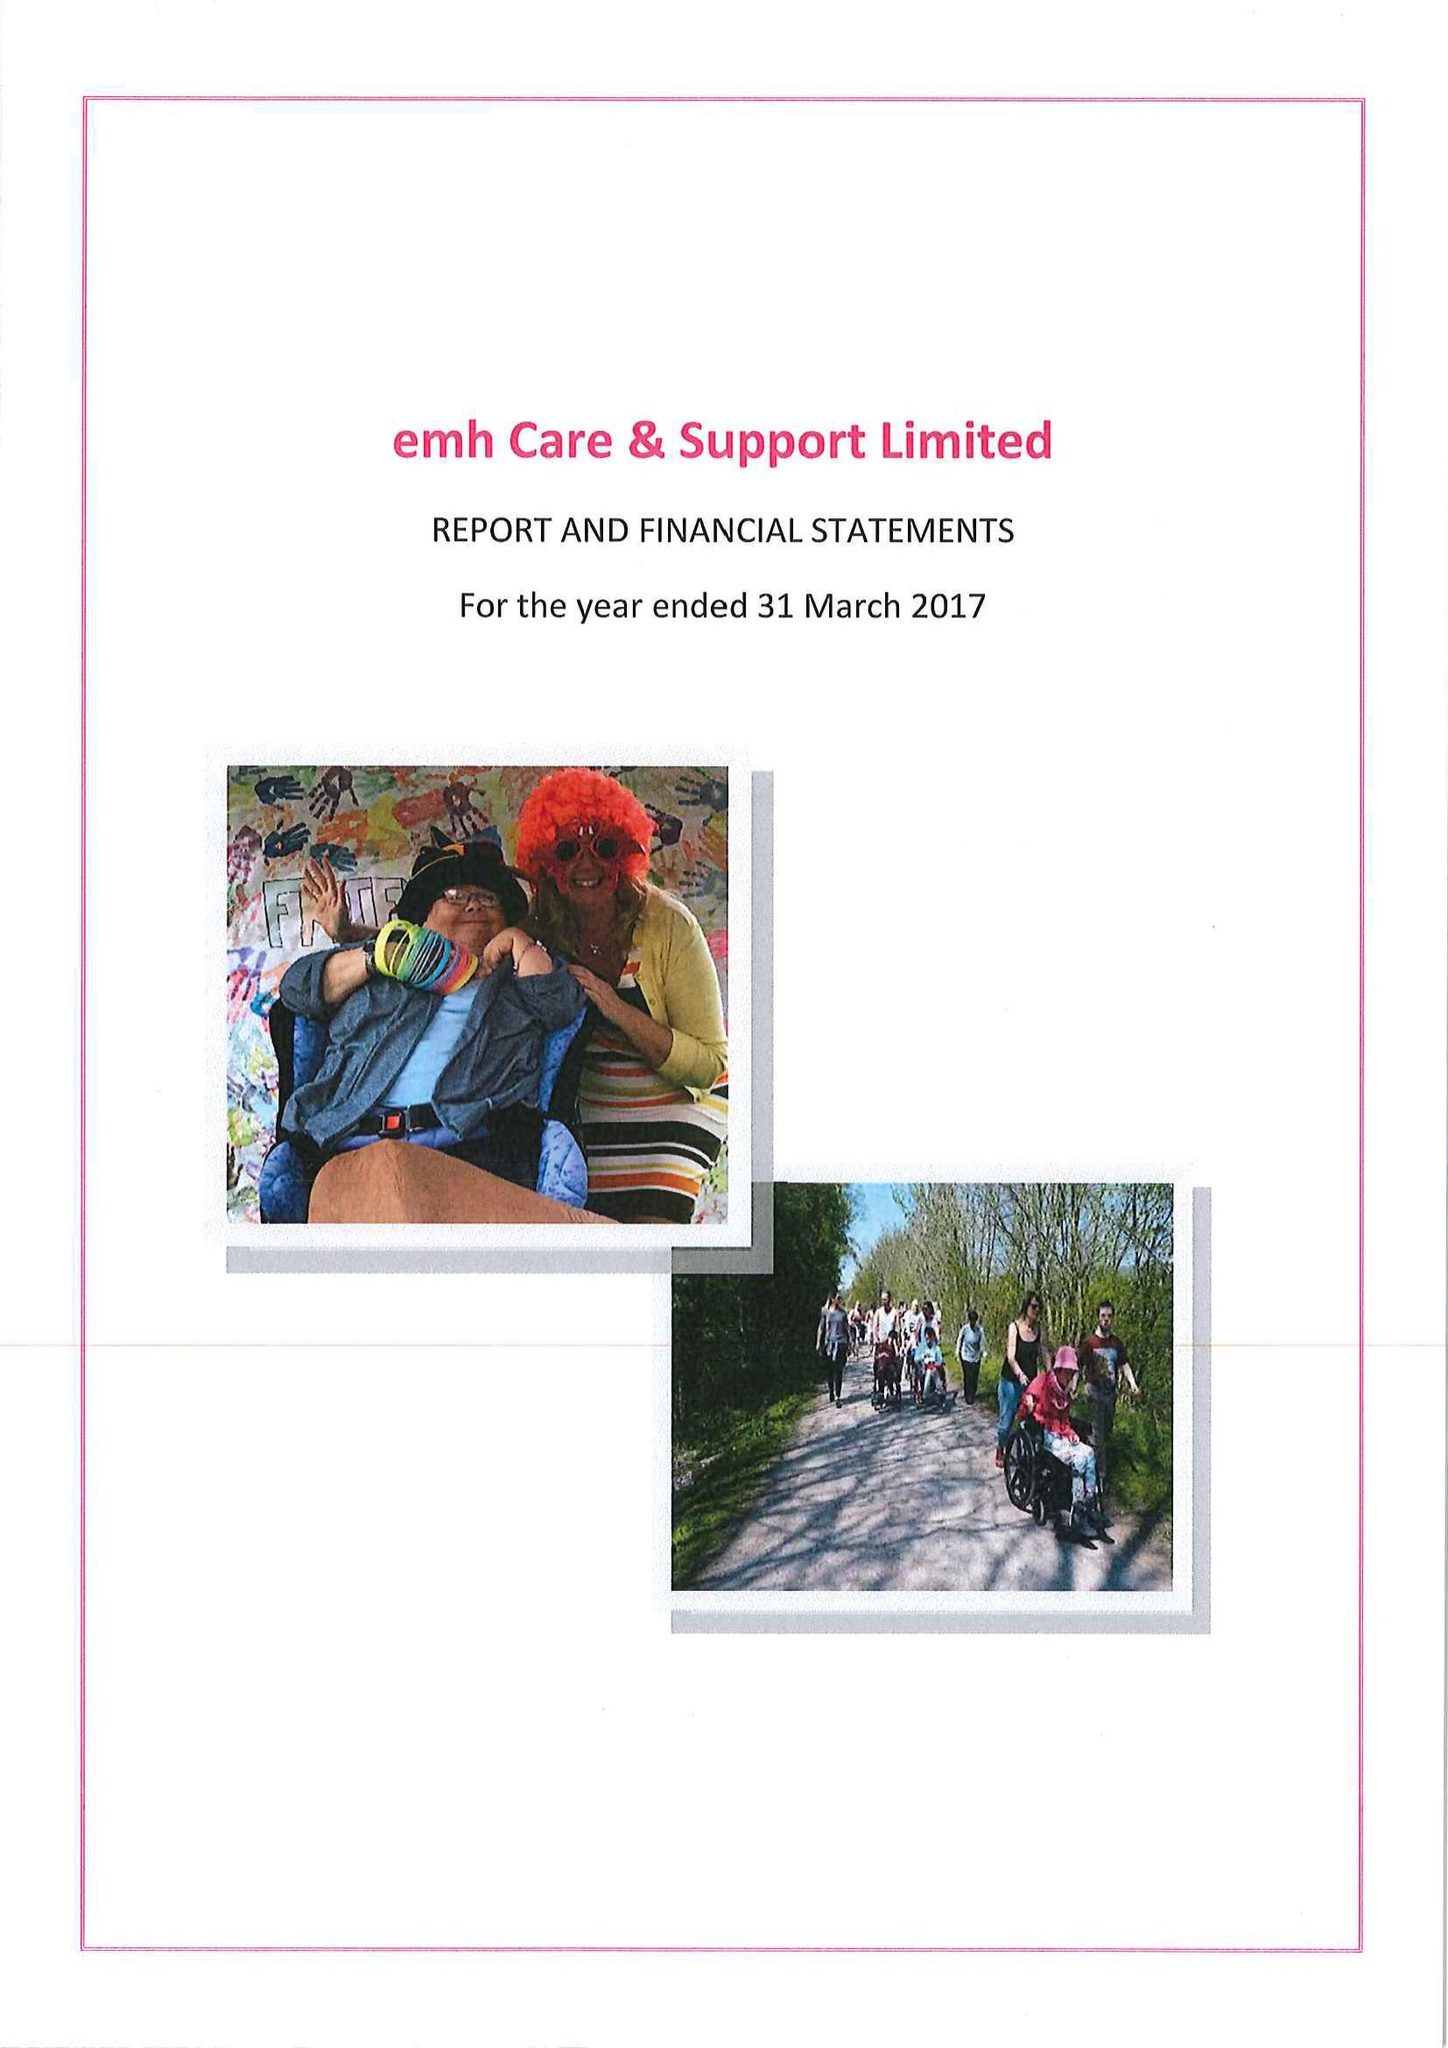What is the value for the spending_annually_in_british_pounds?
Answer the question using a single word or phrase. 15157793.00 